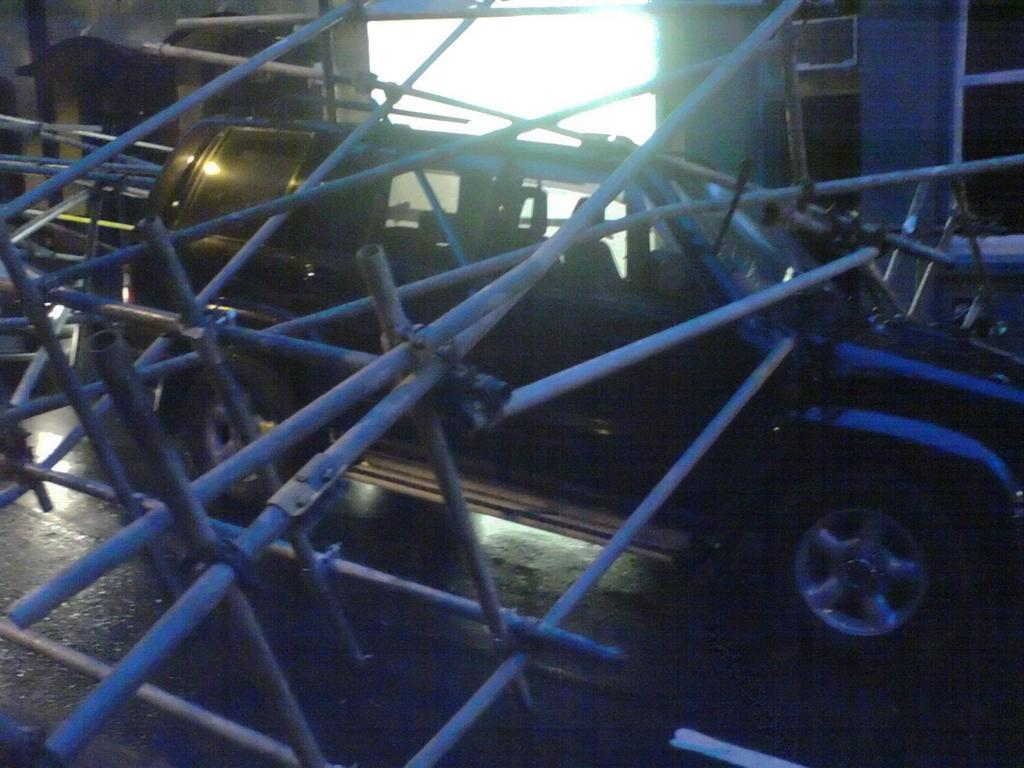What objects are located in the front of the image? There are rods in the front of the image. What is the main subject in the center of the image? There is a car in the center of the image. What color is the car? The car is black in color. What can be seen in the background of the image? There is a wall and windows in the background of the image. How many cats are sitting on the car in the image? There are no cats present in the image; it only features rods, a car, a wall, and windows. 